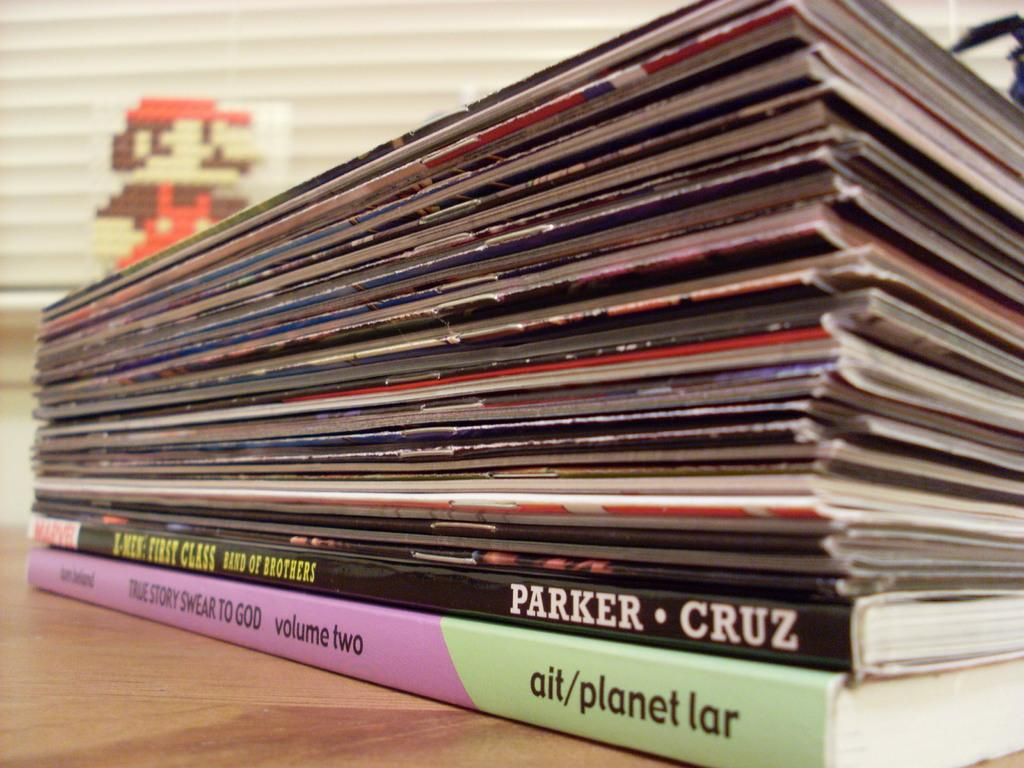<image>
Summarize the visual content of the image. A stack of magazine with two books on the bottom which one book is titled True Story Swear To God. 